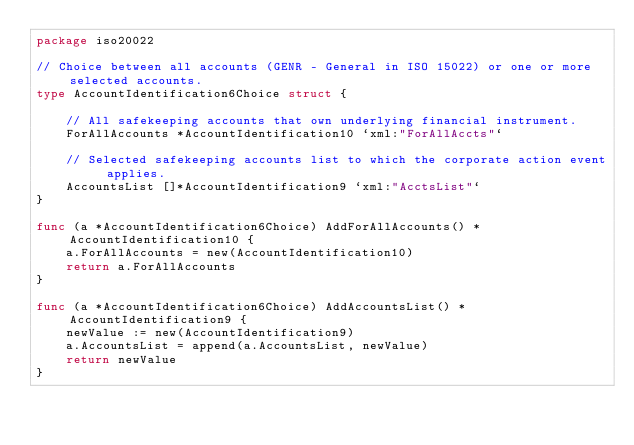<code> <loc_0><loc_0><loc_500><loc_500><_Go_>package iso20022

// Choice between all accounts (GENR - General in ISO 15022) or one or more selected accounts.
type AccountIdentification6Choice struct {

	// All safekeeping accounts that own underlying financial instrument.
	ForAllAccounts *AccountIdentification10 `xml:"ForAllAccts"`

	// Selected safekeeping accounts list to which the corporate action event applies.
	AccountsList []*AccountIdentification9 `xml:"AcctsList"`
}

func (a *AccountIdentification6Choice) AddForAllAccounts() *AccountIdentification10 {
	a.ForAllAccounts = new(AccountIdentification10)
	return a.ForAllAccounts
}

func (a *AccountIdentification6Choice) AddAccountsList() *AccountIdentification9 {
	newValue := new(AccountIdentification9)
	a.AccountsList = append(a.AccountsList, newValue)
	return newValue
}
</code> 